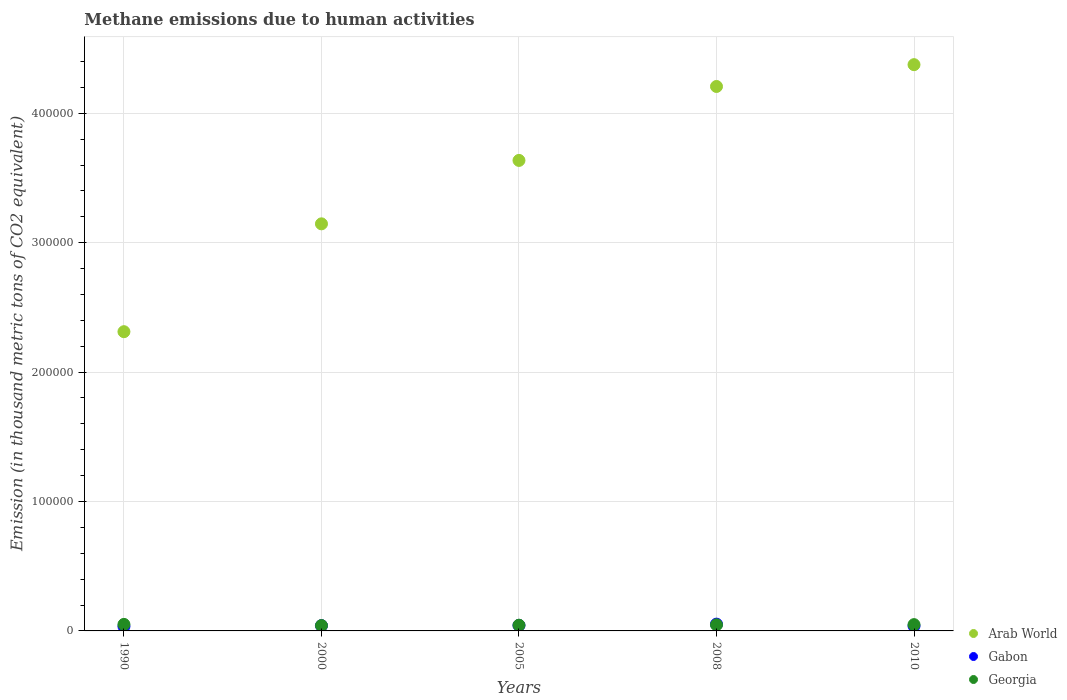How many different coloured dotlines are there?
Provide a short and direct response. 3. Is the number of dotlines equal to the number of legend labels?
Your response must be concise. Yes. What is the amount of methane emitted in Arab World in 2000?
Provide a short and direct response. 3.15e+05. Across all years, what is the maximum amount of methane emitted in Gabon?
Your response must be concise. 5247.8. Across all years, what is the minimum amount of methane emitted in Arab World?
Offer a very short reply. 2.31e+05. In which year was the amount of methane emitted in Arab World maximum?
Your answer should be compact. 2010. What is the total amount of methane emitted in Georgia in the graph?
Provide a succinct answer. 2.32e+04. What is the difference between the amount of methane emitted in Georgia in 1990 and that in 2005?
Offer a terse response. 623.8. What is the difference between the amount of methane emitted in Gabon in 1990 and the amount of methane emitted in Georgia in 2005?
Provide a short and direct response. -934.7. What is the average amount of methane emitted in Georgia per year?
Offer a terse response. 4631.86. In the year 1990, what is the difference between the amount of methane emitted in Georgia and amount of methane emitted in Arab World?
Your answer should be compact. -2.26e+05. What is the ratio of the amount of methane emitted in Gabon in 1990 to that in 2010?
Provide a short and direct response. 0.91. What is the difference between the highest and the second highest amount of methane emitted in Arab World?
Offer a terse response. 1.69e+04. What is the difference between the highest and the lowest amount of methane emitted in Arab World?
Make the answer very short. 2.06e+05. Is the sum of the amount of methane emitted in Georgia in 1990 and 2010 greater than the maximum amount of methane emitted in Gabon across all years?
Offer a terse response. Yes. Is it the case that in every year, the sum of the amount of methane emitted in Georgia and amount of methane emitted in Arab World  is greater than the amount of methane emitted in Gabon?
Ensure brevity in your answer.  Yes. How many dotlines are there?
Provide a succinct answer. 3. Does the graph contain any zero values?
Provide a succinct answer. No. Where does the legend appear in the graph?
Give a very brief answer. Bottom right. How are the legend labels stacked?
Your response must be concise. Vertical. What is the title of the graph?
Give a very brief answer. Methane emissions due to human activities. What is the label or title of the X-axis?
Provide a short and direct response. Years. What is the label or title of the Y-axis?
Offer a very short reply. Emission (in thousand metric tons of CO2 equivalent). What is the Emission (in thousand metric tons of CO2 equivalent) of Arab World in 1990?
Provide a short and direct response. 2.31e+05. What is the Emission (in thousand metric tons of CO2 equivalent) of Gabon in 1990?
Keep it short and to the point. 3478.5. What is the Emission (in thousand metric tons of CO2 equivalent) in Georgia in 1990?
Your answer should be very brief. 5037. What is the Emission (in thousand metric tons of CO2 equivalent) in Arab World in 2000?
Your response must be concise. 3.15e+05. What is the Emission (in thousand metric tons of CO2 equivalent) of Gabon in 2000?
Keep it short and to the point. 4082.1. What is the Emission (in thousand metric tons of CO2 equivalent) of Georgia in 2000?
Ensure brevity in your answer.  4137.4. What is the Emission (in thousand metric tons of CO2 equivalent) of Arab World in 2005?
Your answer should be very brief. 3.64e+05. What is the Emission (in thousand metric tons of CO2 equivalent) of Gabon in 2005?
Your answer should be very brief. 4298.1. What is the Emission (in thousand metric tons of CO2 equivalent) in Georgia in 2005?
Provide a short and direct response. 4413.2. What is the Emission (in thousand metric tons of CO2 equivalent) in Arab World in 2008?
Provide a short and direct response. 4.21e+05. What is the Emission (in thousand metric tons of CO2 equivalent) in Gabon in 2008?
Provide a short and direct response. 5247.8. What is the Emission (in thousand metric tons of CO2 equivalent) of Georgia in 2008?
Make the answer very short. 4708.2. What is the Emission (in thousand metric tons of CO2 equivalent) in Arab World in 2010?
Keep it short and to the point. 4.38e+05. What is the Emission (in thousand metric tons of CO2 equivalent) of Gabon in 2010?
Provide a succinct answer. 3817.5. What is the Emission (in thousand metric tons of CO2 equivalent) of Georgia in 2010?
Offer a terse response. 4863.5. Across all years, what is the maximum Emission (in thousand metric tons of CO2 equivalent) in Arab World?
Ensure brevity in your answer.  4.38e+05. Across all years, what is the maximum Emission (in thousand metric tons of CO2 equivalent) in Gabon?
Keep it short and to the point. 5247.8. Across all years, what is the maximum Emission (in thousand metric tons of CO2 equivalent) in Georgia?
Offer a terse response. 5037. Across all years, what is the minimum Emission (in thousand metric tons of CO2 equivalent) of Arab World?
Offer a very short reply. 2.31e+05. Across all years, what is the minimum Emission (in thousand metric tons of CO2 equivalent) in Gabon?
Your answer should be very brief. 3478.5. Across all years, what is the minimum Emission (in thousand metric tons of CO2 equivalent) of Georgia?
Keep it short and to the point. 4137.4. What is the total Emission (in thousand metric tons of CO2 equivalent) of Arab World in the graph?
Provide a succinct answer. 1.77e+06. What is the total Emission (in thousand metric tons of CO2 equivalent) of Gabon in the graph?
Your response must be concise. 2.09e+04. What is the total Emission (in thousand metric tons of CO2 equivalent) of Georgia in the graph?
Your response must be concise. 2.32e+04. What is the difference between the Emission (in thousand metric tons of CO2 equivalent) in Arab World in 1990 and that in 2000?
Offer a terse response. -8.33e+04. What is the difference between the Emission (in thousand metric tons of CO2 equivalent) of Gabon in 1990 and that in 2000?
Offer a very short reply. -603.6. What is the difference between the Emission (in thousand metric tons of CO2 equivalent) in Georgia in 1990 and that in 2000?
Provide a short and direct response. 899.6. What is the difference between the Emission (in thousand metric tons of CO2 equivalent) in Arab World in 1990 and that in 2005?
Offer a terse response. -1.32e+05. What is the difference between the Emission (in thousand metric tons of CO2 equivalent) of Gabon in 1990 and that in 2005?
Offer a terse response. -819.6. What is the difference between the Emission (in thousand metric tons of CO2 equivalent) in Georgia in 1990 and that in 2005?
Give a very brief answer. 623.8. What is the difference between the Emission (in thousand metric tons of CO2 equivalent) of Arab World in 1990 and that in 2008?
Your answer should be very brief. -1.89e+05. What is the difference between the Emission (in thousand metric tons of CO2 equivalent) of Gabon in 1990 and that in 2008?
Offer a terse response. -1769.3. What is the difference between the Emission (in thousand metric tons of CO2 equivalent) of Georgia in 1990 and that in 2008?
Keep it short and to the point. 328.8. What is the difference between the Emission (in thousand metric tons of CO2 equivalent) in Arab World in 1990 and that in 2010?
Keep it short and to the point. -2.06e+05. What is the difference between the Emission (in thousand metric tons of CO2 equivalent) of Gabon in 1990 and that in 2010?
Provide a succinct answer. -339. What is the difference between the Emission (in thousand metric tons of CO2 equivalent) of Georgia in 1990 and that in 2010?
Ensure brevity in your answer.  173.5. What is the difference between the Emission (in thousand metric tons of CO2 equivalent) in Arab World in 2000 and that in 2005?
Provide a succinct answer. -4.90e+04. What is the difference between the Emission (in thousand metric tons of CO2 equivalent) of Gabon in 2000 and that in 2005?
Ensure brevity in your answer.  -216. What is the difference between the Emission (in thousand metric tons of CO2 equivalent) in Georgia in 2000 and that in 2005?
Provide a succinct answer. -275.8. What is the difference between the Emission (in thousand metric tons of CO2 equivalent) of Arab World in 2000 and that in 2008?
Ensure brevity in your answer.  -1.06e+05. What is the difference between the Emission (in thousand metric tons of CO2 equivalent) in Gabon in 2000 and that in 2008?
Make the answer very short. -1165.7. What is the difference between the Emission (in thousand metric tons of CO2 equivalent) in Georgia in 2000 and that in 2008?
Provide a short and direct response. -570.8. What is the difference between the Emission (in thousand metric tons of CO2 equivalent) in Arab World in 2000 and that in 2010?
Provide a succinct answer. -1.23e+05. What is the difference between the Emission (in thousand metric tons of CO2 equivalent) of Gabon in 2000 and that in 2010?
Your answer should be compact. 264.6. What is the difference between the Emission (in thousand metric tons of CO2 equivalent) in Georgia in 2000 and that in 2010?
Provide a succinct answer. -726.1. What is the difference between the Emission (in thousand metric tons of CO2 equivalent) in Arab World in 2005 and that in 2008?
Keep it short and to the point. -5.71e+04. What is the difference between the Emission (in thousand metric tons of CO2 equivalent) of Gabon in 2005 and that in 2008?
Provide a short and direct response. -949.7. What is the difference between the Emission (in thousand metric tons of CO2 equivalent) of Georgia in 2005 and that in 2008?
Provide a short and direct response. -295. What is the difference between the Emission (in thousand metric tons of CO2 equivalent) in Arab World in 2005 and that in 2010?
Provide a short and direct response. -7.40e+04. What is the difference between the Emission (in thousand metric tons of CO2 equivalent) in Gabon in 2005 and that in 2010?
Keep it short and to the point. 480.6. What is the difference between the Emission (in thousand metric tons of CO2 equivalent) of Georgia in 2005 and that in 2010?
Your answer should be very brief. -450.3. What is the difference between the Emission (in thousand metric tons of CO2 equivalent) in Arab World in 2008 and that in 2010?
Give a very brief answer. -1.69e+04. What is the difference between the Emission (in thousand metric tons of CO2 equivalent) in Gabon in 2008 and that in 2010?
Your answer should be very brief. 1430.3. What is the difference between the Emission (in thousand metric tons of CO2 equivalent) of Georgia in 2008 and that in 2010?
Offer a terse response. -155.3. What is the difference between the Emission (in thousand metric tons of CO2 equivalent) of Arab World in 1990 and the Emission (in thousand metric tons of CO2 equivalent) of Gabon in 2000?
Make the answer very short. 2.27e+05. What is the difference between the Emission (in thousand metric tons of CO2 equivalent) in Arab World in 1990 and the Emission (in thousand metric tons of CO2 equivalent) in Georgia in 2000?
Give a very brief answer. 2.27e+05. What is the difference between the Emission (in thousand metric tons of CO2 equivalent) in Gabon in 1990 and the Emission (in thousand metric tons of CO2 equivalent) in Georgia in 2000?
Keep it short and to the point. -658.9. What is the difference between the Emission (in thousand metric tons of CO2 equivalent) of Arab World in 1990 and the Emission (in thousand metric tons of CO2 equivalent) of Gabon in 2005?
Make the answer very short. 2.27e+05. What is the difference between the Emission (in thousand metric tons of CO2 equivalent) in Arab World in 1990 and the Emission (in thousand metric tons of CO2 equivalent) in Georgia in 2005?
Your answer should be very brief. 2.27e+05. What is the difference between the Emission (in thousand metric tons of CO2 equivalent) of Gabon in 1990 and the Emission (in thousand metric tons of CO2 equivalent) of Georgia in 2005?
Give a very brief answer. -934.7. What is the difference between the Emission (in thousand metric tons of CO2 equivalent) in Arab World in 1990 and the Emission (in thousand metric tons of CO2 equivalent) in Gabon in 2008?
Provide a short and direct response. 2.26e+05. What is the difference between the Emission (in thousand metric tons of CO2 equivalent) of Arab World in 1990 and the Emission (in thousand metric tons of CO2 equivalent) of Georgia in 2008?
Offer a very short reply. 2.27e+05. What is the difference between the Emission (in thousand metric tons of CO2 equivalent) in Gabon in 1990 and the Emission (in thousand metric tons of CO2 equivalent) in Georgia in 2008?
Your response must be concise. -1229.7. What is the difference between the Emission (in thousand metric tons of CO2 equivalent) of Arab World in 1990 and the Emission (in thousand metric tons of CO2 equivalent) of Gabon in 2010?
Your answer should be compact. 2.27e+05. What is the difference between the Emission (in thousand metric tons of CO2 equivalent) in Arab World in 1990 and the Emission (in thousand metric tons of CO2 equivalent) in Georgia in 2010?
Provide a short and direct response. 2.26e+05. What is the difference between the Emission (in thousand metric tons of CO2 equivalent) in Gabon in 1990 and the Emission (in thousand metric tons of CO2 equivalent) in Georgia in 2010?
Offer a very short reply. -1385. What is the difference between the Emission (in thousand metric tons of CO2 equivalent) of Arab World in 2000 and the Emission (in thousand metric tons of CO2 equivalent) of Gabon in 2005?
Offer a very short reply. 3.10e+05. What is the difference between the Emission (in thousand metric tons of CO2 equivalent) of Arab World in 2000 and the Emission (in thousand metric tons of CO2 equivalent) of Georgia in 2005?
Offer a very short reply. 3.10e+05. What is the difference between the Emission (in thousand metric tons of CO2 equivalent) in Gabon in 2000 and the Emission (in thousand metric tons of CO2 equivalent) in Georgia in 2005?
Your answer should be very brief. -331.1. What is the difference between the Emission (in thousand metric tons of CO2 equivalent) in Arab World in 2000 and the Emission (in thousand metric tons of CO2 equivalent) in Gabon in 2008?
Offer a very short reply. 3.09e+05. What is the difference between the Emission (in thousand metric tons of CO2 equivalent) of Arab World in 2000 and the Emission (in thousand metric tons of CO2 equivalent) of Georgia in 2008?
Make the answer very short. 3.10e+05. What is the difference between the Emission (in thousand metric tons of CO2 equivalent) in Gabon in 2000 and the Emission (in thousand metric tons of CO2 equivalent) in Georgia in 2008?
Your response must be concise. -626.1. What is the difference between the Emission (in thousand metric tons of CO2 equivalent) in Arab World in 2000 and the Emission (in thousand metric tons of CO2 equivalent) in Gabon in 2010?
Provide a succinct answer. 3.11e+05. What is the difference between the Emission (in thousand metric tons of CO2 equivalent) in Arab World in 2000 and the Emission (in thousand metric tons of CO2 equivalent) in Georgia in 2010?
Provide a succinct answer. 3.10e+05. What is the difference between the Emission (in thousand metric tons of CO2 equivalent) of Gabon in 2000 and the Emission (in thousand metric tons of CO2 equivalent) of Georgia in 2010?
Keep it short and to the point. -781.4. What is the difference between the Emission (in thousand metric tons of CO2 equivalent) of Arab World in 2005 and the Emission (in thousand metric tons of CO2 equivalent) of Gabon in 2008?
Provide a succinct answer. 3.58e+05. What is the difference between the Emission (in thousand metric tons of CO2 equivalent) of Arab World in 2005 and the Emission (in thousand metric tons of CO2 equivalent) of Georgia in 2008?
Your answer should be very brief. 3.59e+05. What is the difference between the Emission (in thousand metric tons of CO2 equivalent) of Gabon in 2005 and the Emission (in thousand metric tons of CO2 equivalent) of Georgia in 2008?
Your answer should be compact. -410.1. What is the difference between the Emission (in thousand metric tons of CO2 equivalent) in Arab World in 2005 and the Emission (in thousand metric tons of CO2 equivalent) in Gabon in 2010?
Ensure brevity in your answer.  3.60e+05. What is the difference between the Emission (in thousand metric tons of CO2 equivalent) in Arab World in 2005 and the Emission (in thousand metric tons of CO2 equivalent) in Georgia in 2010?
Keep it short and to the point. 3.59e+05. What is the difference between the Emission (in thousand metric tons of CO2 equivalent) of Gabon in 2005 and the Emission (in thousand metric tons of CO2 equivalent) of Georgia in 2010?
Make the answer very short. -565.4. What is the difference between the Emission (in thousand metric tons of CO2 equivalent) in Arab World in 2008 and the Emission (in thousand metric tons of CO2 equivalent) in Gabon in 2010?
Make the answer very short. 4.17e+05. What is the difference between the Emission (in thousand metric tons of CO2 equivalent) of Arab World in 2008 and the Emission (in thousand metric tons of CO2 equivalent) of Georgia in 2010?
Your response must be concise. 4.16e+05. What is the difference between the Emission (in thousand metric tons of CO2 equivalent) in Gabon in 2008 and the Emission (in thousand metric tons of CO2 equivalent) in Georgia in 2010?
Make the answer very short. 384.3. What is the average Emission (in thousand metric tons of CO2 equivalent) in Arab World per year?
Ensure brevity in your answer.  3.54e+05. What is the average Emission (in thousand metric tons of CO2 equivalent) in Gabon per year?
Ensure brevity in your answer.  4184.8. What is the average Emission (in thousand metric tons of CO2 equivalent) in Georgia per year?
Keep it short and to the point. 4631.86. In the year 1990, what is the difference between the Emission (in thousand metric tons of CO2 equivalent) in Arab World and Emission (in thousand metric tons of CO2 equivalent) in Gabon?
Provide a succinct answer. 2.28e+05. In the year 1990, what is the difference between the Emission (in thousand metric tons of CO2 equivalent) in Arab World and Emission (in thousand metric tons of CO2 equivalent) in Georgia?
Keep it short and to the point. 2.26e+05. In the year 1990, what is the difference between the Emission (in thousand metric tons of CO2 equivalent) in Gabon and Emission (in thousand metric tons of CO2 equivalent) in Georgia?
Your answer should be compact. -1558.5. In the year 2000, what is the difference between the Emission (in thousand metric tons of CO2 equivalent) of Arab World and Emission (in thousand metric tons of CO2 equivalent) of Gabon?
Make the answer very short. 3.10e+05. In the year 2000, what is the difference between the Emission (in thousand metric tons of CO2 equivalent) in Arab World and Emission (in thousand metric tons of CO2 equivalent) in Georgia?
Offer a terse response. 3.10e+05. In the year 2000, what is the difference between the Emission (in thousand metric tons of CO2 equivalent) of Gabon and Emission (in thousand metric tons of CO2 equivalent) of Georgia?
Give a very brief answer. -55.3. In the year 2005, what is the difference between the Emission (in thousand metric tons of CO2 equivalent) in Arab World and Emission (in thousand metric tons of CO2 equivalent) in Gabon?
Your response must be concise. 3.59e+05. In the year 2005, what is the difference between the Emission (in thousand metric tons of CO2 equivalent) in Arab World and Emission (in thousand metric tons of CO2 equivalent) in Georgia?
Your answer should be very brief. 3.59e+05. In the year 2005, what is the difference between the Emission (in thousand metric tons of CO2 equivalent) of Gabon and Emission (in thousand metric tons of CO2 equivalent) of Georgia?
Provide a succinct answer. -115.1. In the year 2008, what is the difference between the Emission (in thousand metric tons of CO2 equivalent) in Arab World and Emission (in thousand metric tons of CO2 equivalent) in Gabon?
Make the answer very short. 4.15e+05. In the year 2008, what is the difference between the Emission (in thousand metric tons of CO2 equivalent) in Arab World and Emission (in thousand metric tons of CO2 equivalent) in Georgia?
Keep it short and to the point. 4.16e+05. In the year 2008, what is the difference between the Emission (in thousand metric tons of CO2 equivalent) in Gabon and Emission (in thousand metric tons of CO2 equivalent) in Georgia?
Offer a terse response. 539.6. In the year 2010, what is the difference between the Emission (in thousand metric tons of CO2 equivalent) of Arab World and Emission (in thousand metric tons of CO2 equivalent) of Gabon?
Your answer should be very brief. 4.34e+05. In the year 2010, what is the difference between the Emission (in thousand metric tons of CO2 equivalent) in Arab World and Emission (in thousand metric tons of CO2 equivalent) in Georgia?
Your answer should be compact. 4.33e+05. In the year 2010, what is the difference between the Emission (in thousand metric tons of CO2 equivalent) in Gabon and Emission (in thousand metric tons of CO2 equivalent) in Georgia?
Provide a succinct answer. -1046. What is the ratio of the Emission (in thousand metric tons of CO2 equivalent) in Arab World in 1990 to that in 2000?
Give a very brief answer. 0.74. What is the ratio of the Emission (in thousand metric tons of CO2 equivalent) of Gabon in 1990 to that in 2000?
Your response must be concise. 0.85. What is the ratio of the Emission (in thousand metric tons of CO2 equivalent) of Georgia in 1990 to that in 2000?
Your response must be concise. 1.22. What is the ratio of the Emission (in thousand metric tons of CO2 equivalent) in Arab World in 1990 to that in 2005?
Provide a succinct answer. 0.64. What is the ratio of the Emission (in thousand metric tons of CO2 equivalent) of Gabon in 1990 to that in 2005?
Provide a short and direct response. 0.81. What is the ratio of the Emission (in thousand metric tons of CO2 equivalent) of Georgia in 1990 to that in 2005?
Keep it short and to the point. 1.14. What is the ratio of the Emission (in thousand metric tons of CO2 equivalent) in Arab World in 1990 to that in 2008?
Keep it short and to the point. 0.55. What is the ratio of the Emission (in thousand metric tons of CO2 equivalent) in Gabon in 1990 to that in 2008?
Your answer should be very brief. 0.66. What is the ratio of the Emission (in thousand metric tons of CO2 equivalent) of Georgia in 1990 to that in 2008?
Keep it short and to the point. 1.07. What is the ratio of the Emission (in thousand metric tons of CO2 equivalent) in Arab World in 1990 to that in 2010?
Your answer should be very brief. 0.53. What is the ratio of the Emission (in thousand metric tons of CO2 equivalent) in Gabon in 1990 to that in 2010?
Offer a terse response. 0.91. What is the ratio of the Emission (in thousand metric tons of CO2 equivalent) of Georgia in 1990 to that in 2010?
Your answer should be very brief. 1.04. What is the ratio of the Emission (in thousand metric tons of CO2 equivalent) in Arab World in 2000 to that in 2005?
Your response must be concise. 0.87. What is the ratio of the Emission (in thousand metric tons of CO2 equivalent) of Gabon in 2000 to that in 2005?
Your answer should be very brief. 0.95. What is the ratio of the Emission (in thousand metric tons of CO2 equivalent) in Arab World in 2000 to that in 2008?
Your response must be concise. 0.75. What is the ratio of the Emission (in thousand metric tons of CO2 equivalent) in Gabon in 2000 to that in 2008?
Your answer should be compact. 0.78. What is the ratio of the Emission (in thousand metric tons of CO2 equivalent) in Georgia in 2000 to that in 2008?
Provide a short and direct response. 0.88. What is the ratio of the Emission (in thousand metric tons of CO2 equivalent) in Arab World in 2000 to that in 2010?
Your answer should be very brief. 0.72. What is the ratio of the Emission (in thousand metric tons of CO2 equivalent) in Gabon in 2000 to that in 2010?
Your answer should be very brief. 1.07. What is the ratio of the Emission (in thousand metric tons of CO2 equivalent) of Georgia in 2000 to that in 2010?
Your answer should be very brief. 0.85. What is the ratio of the Emission (in thousand metric tons of CO2 equivalent) of Arab World in 2005 to that in 2008?
Offer a very short reply. 0.86. What is the ratio of the Emission (in thousand metric tons of CO2 equivalent) of Gabon in 2005 to that in 2008?
Provide a succinct answer. 0.82. What is the ratio of the Emission (in thousand metric tons of CO2 equivalent) of Georgia in 2005 to that in 2008?
Your answer should be very brief. 0.94. What is the ratio of the Emission (in thousand metric tons of CO2 equivalent) of Arab World in 2005 to that in 2010?
Your response must be concise. 0.83. What is the ratio of the Emission (in thousand metric tons of CO2 equivalent) of Gabon in 2005 to that in 2010?
Your answer should be very brief. 1.13. What is the ratio of the Emission (in thousand metric tons of CO2 equivalent) in Georgia in 2005 to that in 2010?
Provide a short and direct response. 0.91. What is the ratio of the Emission (in thousand metric tons of CO2 equivalent) in Arab World in 2008 to that in 2010?
Offer a terse response. 0.96. What is the ratio of the Emission (in thousand metric tons of CO2 equivalent) of Gabon in 2008 to that in 2010?
Provide a succinct answer. 1.37. What is the ratio of the Emission (in thousand metric tons of CO2 equivalent) of Georgia in 2008 to that in 2010?
Give a very brief answer. 0.97. What is the difference between the highest and the second highest Emission (in thousand metric tons of CO2 equivalent) of Arab World?
Provide a short and direct response. 1.69e+04. What is the difference between the highest and the second highest Emission (in thousand metric tons of CO2 equivalent) in Gabon?
Give a very brief answer. 949.7. What is the difference between the highest and the second highest Emission (in thousand metric tons of CO2 equivalent) of Georgia?
Give a very brief answer. 173.5. What is the difference between the highest and the lowest Emission (in thousand metric tons of CO2 equivalent) in Arab World?
Your response must be concise. 2.06e+05. What is the difference between the highest and the lowest Emission (in thousand metric tons of CO2 equivalent) of Gabon?
Ensure brevity in your answer.  1769.3. What is the difference between the highest and the lowest Emission (in thousand metric tons of CO2 equivalent) of Georgia?
Provide a short and direct response. 899.6. 